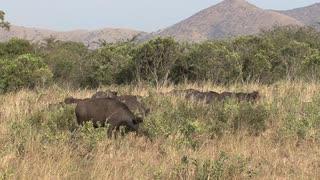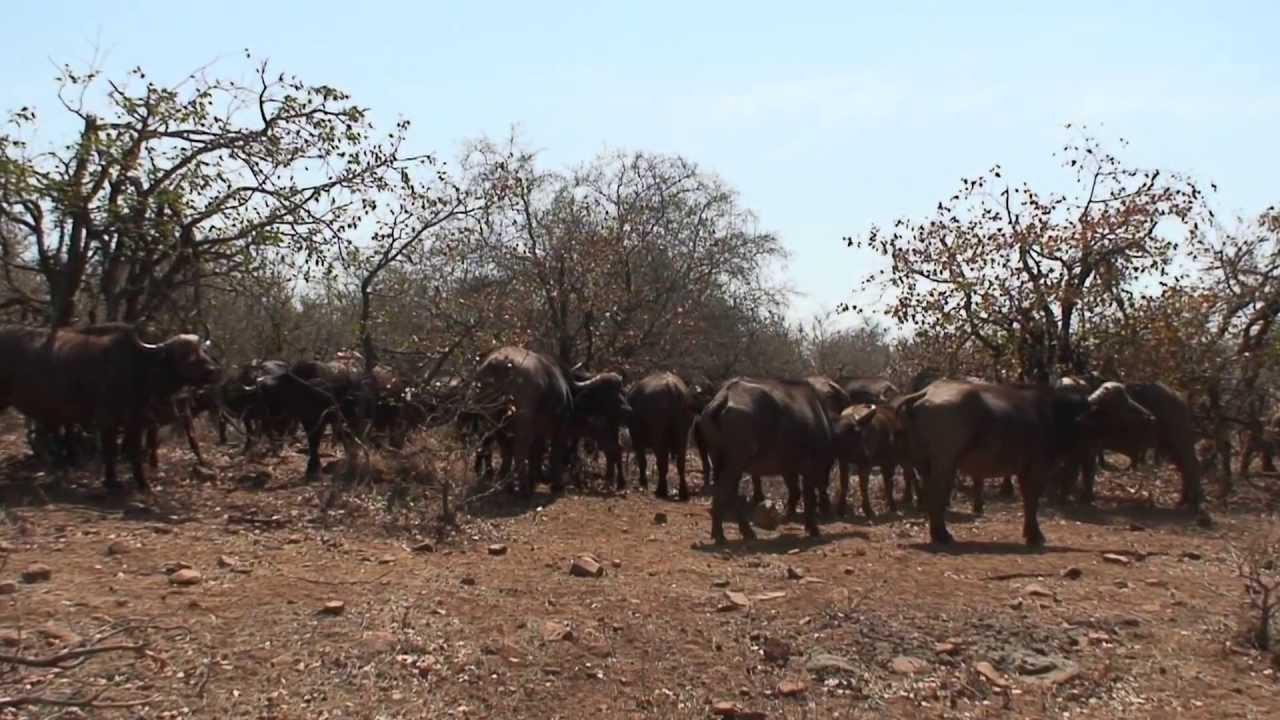The first image is the image on the left, the second image is the image on the right. Analyze the images presented: Is the assertion "In one image, most of the water buffalo stand with their rears turned toward the camera." valid? Answer yes or no. Yes. The first image is the image on the left, the second image is the image on the right. Considering the images on both sides, is "Both images contains an easily visible group of buffalo with at least one facing forward and no water." valid? Answer yes or no. No. 